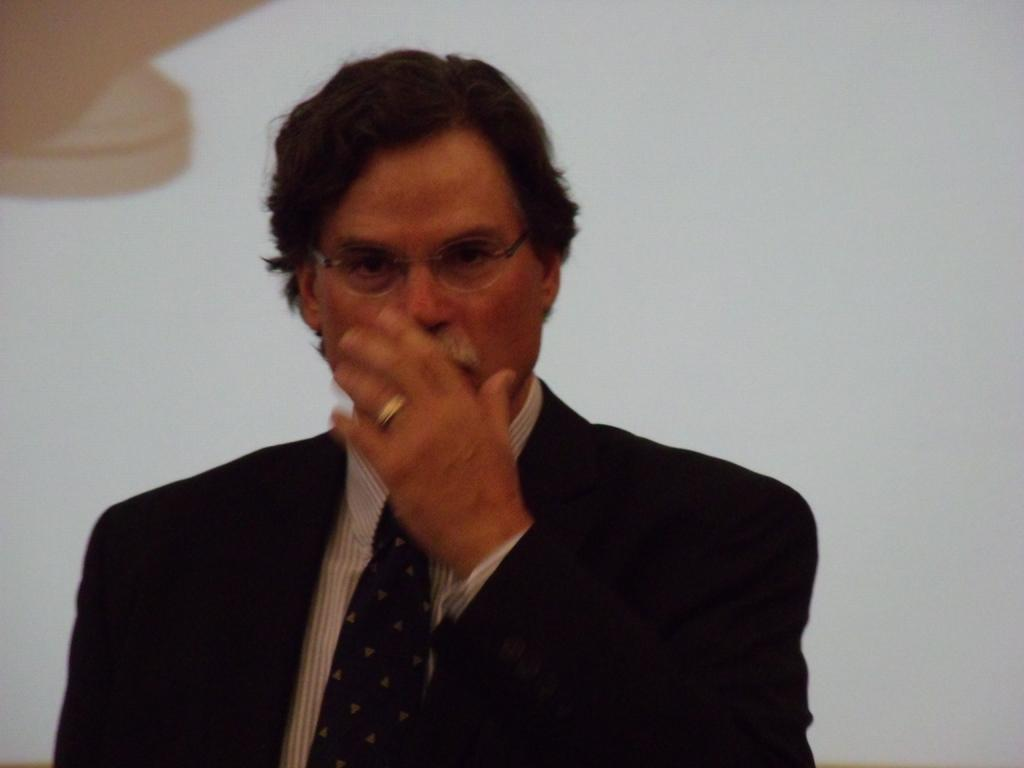Who is present in the image? There is a man in the picture. What is the man wearing on his face? The man is wearing spectacles. What type of jewelry is the man wearing? The man is wearing a ring. What type of clothing is the man wearing? The man is wearing a suit. Where is the man positioned in the image? The man is standing near a wall. What sound can be heard coming from the man's account in the image? There is no sound or account present in the image; it only features a man standing near a wall. 